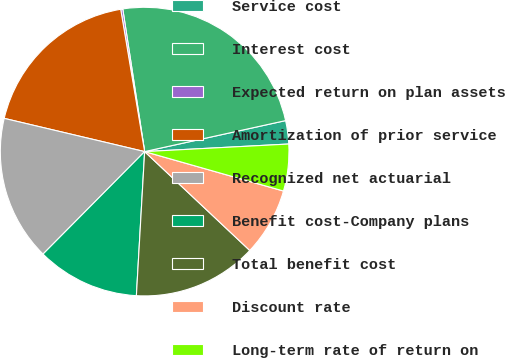Convert chart. <chart><loc_0><loc_0><loc_500><loc_500><pie_chart><fcel>Service cost<fcel>Interest cost<fcel>Expected return on plan assets<fcel>Amortization of prior service<fcel>Recognized net actuarial<fcel>Benefit cost-Company plans<fcel>Total benefit cost<fcel>Discount rate<fcel>Long-term rate of return on<nl><fcel>2.61%<fcel>23.98%<fcel>0.23%<fcel>18.65%<fcel>16.27%<fcel>11.52%<fcel>13.9%<fcel>7.61%<fcel>5.24%<nl></chart> 